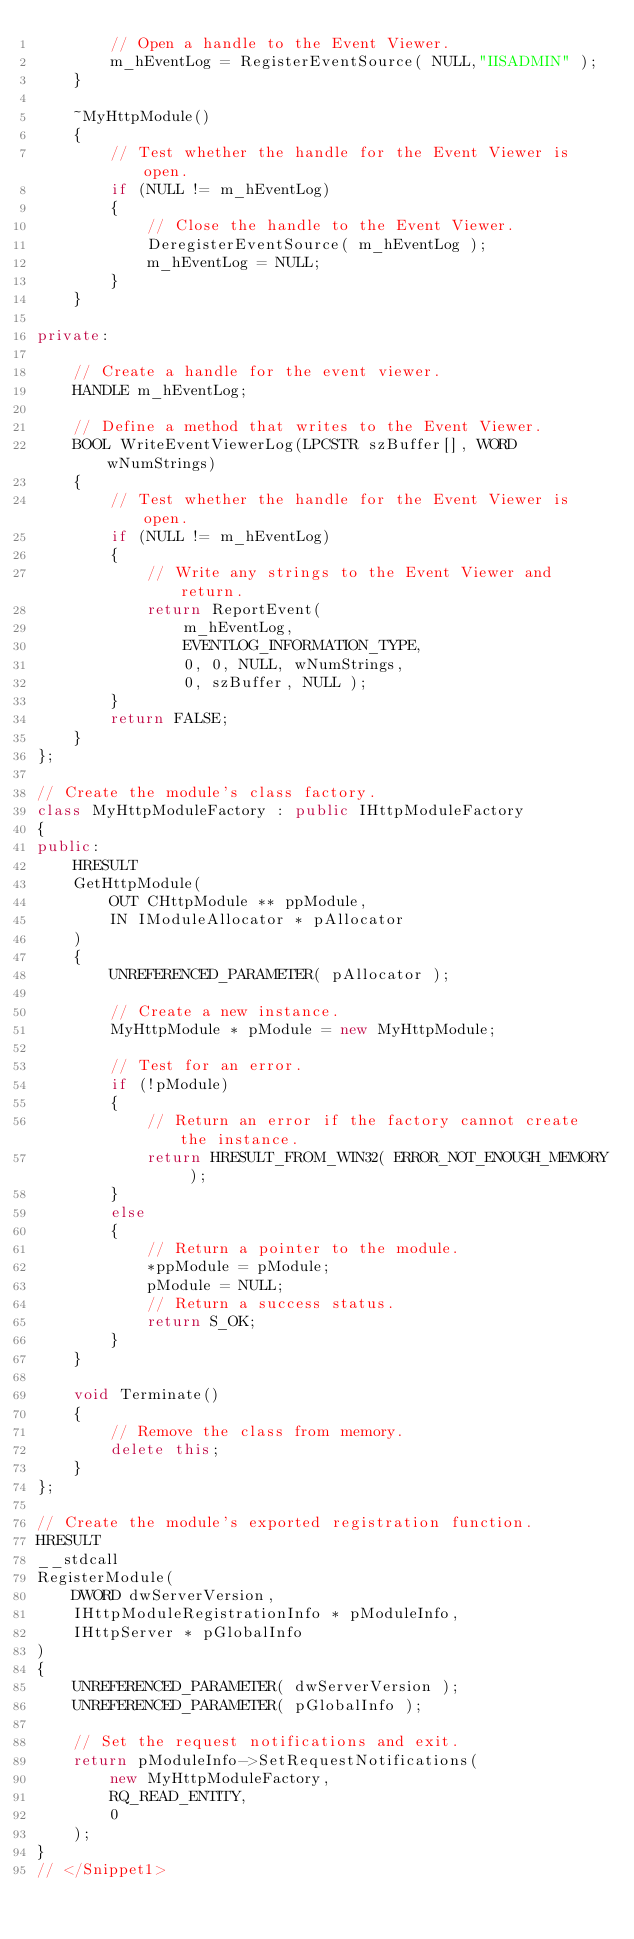Convert code to text. <code><loc_0><loc_0><loc_500><loc_500><_C++_>        // Open a handle to the Event Viewer.
        m_hEventLog = RegisterEventSource( NULL,"IISADMIN" );
    }

    ~MyHttpModule()
    {
        // Test whether the handle for the Event Viewer is open.
        if (NULL != m_hEventLog)
        {
            // Close the handle to the Event Viewer.
            DeregisterEventSource( m_hEventLog );
            m_hEventLog = NULL;
        }
    }

private:

    // Create a handle for the event viewer.
    HANDLE m_hEventLog;

    // Define a method that writes to the Event Viewer.
    BOOL WriteEventViewerLog(LPCSTR szBuffer[], WORD wNumStrings)
    {
        // Test whether the handle for the Event Viewer is open.
        if (NULL != m_hEventLog)
        {
            // Write any strings to the Event Viewer and return.
            return ReportEvent(
                m_hEventLog,
                EVENTLOG_INFORMATION_TYPE,
                0, 0, NULL, wNumStrings,
                0, szBuffer, NULL );
        }
        return FALSE;
    }
};

// Create the module's class factory.
class MyHttpModuleFactory : public IHttpModuleFactory
{
public:
    HRESULT
    GetHttpModule(
        OUT CHttpModule ** ppModule, 
        IN IModuleAllocator * pAllocator
    )
    {
        UNREFERENCED_PARAMETER( pAllocator );

        // Create a new instance.
        MyHttpModule * pModule = new MyHttpModule;

        // Test for an error.
        if (!pModule)
        {
            // Return an error if the factory cannot create the instance.
            return HRESULT_FROM_WIN32( ERROR_NOT_ENOUGH_MEMORY );
        }
        else
        {
            // Return a pointer to the module.
            *ppModule = pModule;
            pModule = NULL;
            // Return a success status.
            return S_OK;
        }            
    }

    void Terminate()
    {
        // Remove the class from memory.
        delete this;
    }
};

// Create the module's exported registration function.
HRESULT
__stdcall
RegisterModule(
    DWORD dwServerVersion,
    IHttpModuleRegistrationInfo * pModuleInfo,
    IHttpServer * pGlobalInfo
)
{
    UNREFERENCED_PARAMETER( dwServerVersion );
    UNREFERENCED_PARAMETER( pGlobalInfo );

    // Set the request notifications and exit.
    return pModuleInfo->SetRequestNotifications(
        new MyHttpModuleFactory,
        RQ_READ_ENTITY,
        0
    );
}
// </Snippet1></code> 